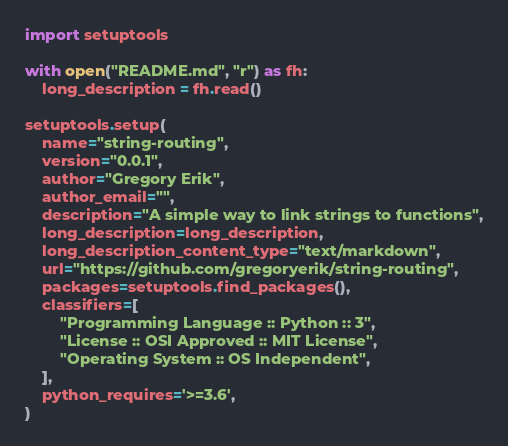<code> <loc_0><loc_0><loc_500><loc_500><_Python_>import setuptools

with open("README.md", "r") as fh:
    long_description = fh.read()

setuptools.setup(
    name="string-routing",
    version="0.0.1",
    author="Gregory Erik",
    author_email="",
    description="A simple way to link strings to functions",
    long_description=long_description,
    long_description_content_type="text/markdown",
    url="https://github.com/gregoryerik/string-routing",
    packages=setuptools.find_packages(),
    classifiers=[
        "Programming Language :: Python :: 3",
        "License :: OSI Approved :: MIT License",
        "Operating System :: OS Independent",
    ],
    python_requires='>=3.6',
)
</code> 